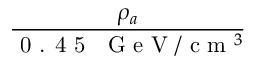<formula> <loc_0><loc_0><loc_500><loc_500>\frac { \rho _ { a } } { 0 . 4 5 G e V / c m ^ { 3 } }</formula> 